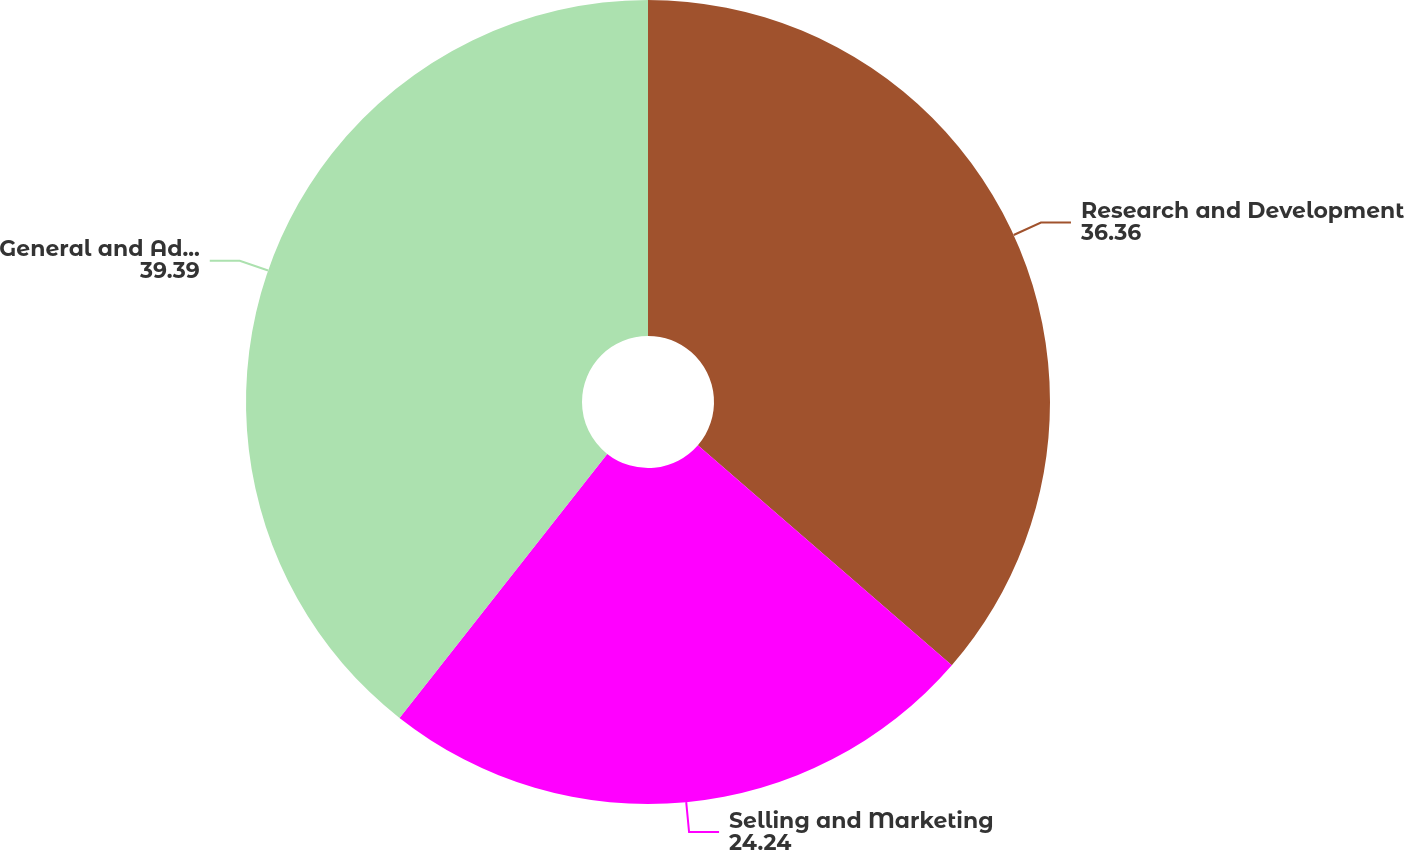Convert chart to OTSL. <chart><loc_0><loc_0><loc_500><loc_500><pie_chart><fcel>Research and Development<fcel>Selling and Marketing<fcel>General and Administrative<nl><fcel>36.36%<fcel>24.24%<fcel>39.39%<nl></chart> 